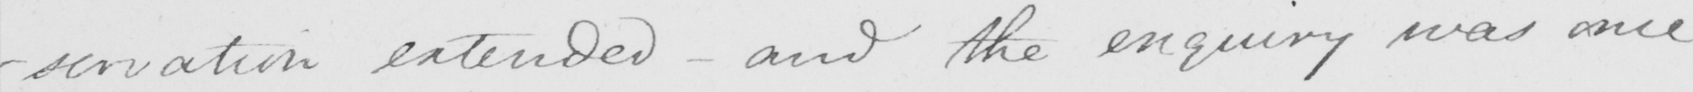What does this handwritten line say? -servation extended  _  and the enquiry was once 